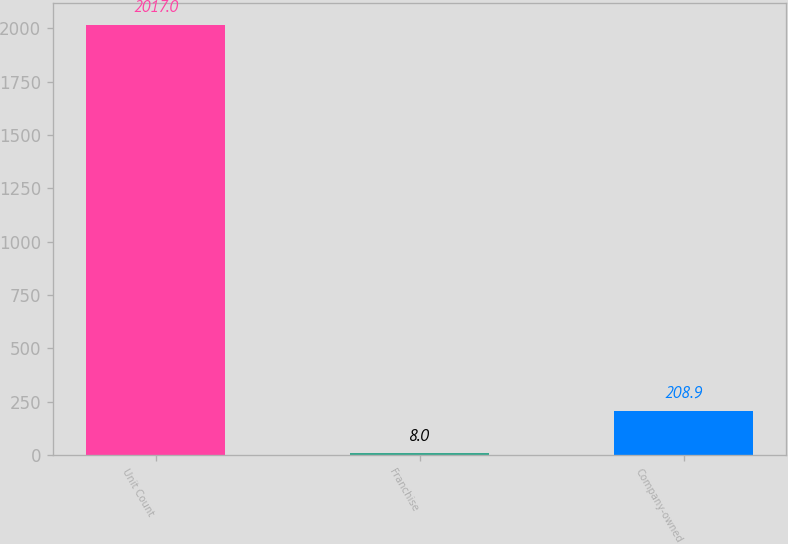Convert chart to OTSL. <chart><loc_0><loc_0><loc_500><loc_500><bar_chart><fcel>Unit Count<fcel>Franchise<fcel>Company-owned<nl><fcel>2017<fcel>8<fcel>208.9<nl></chart> 